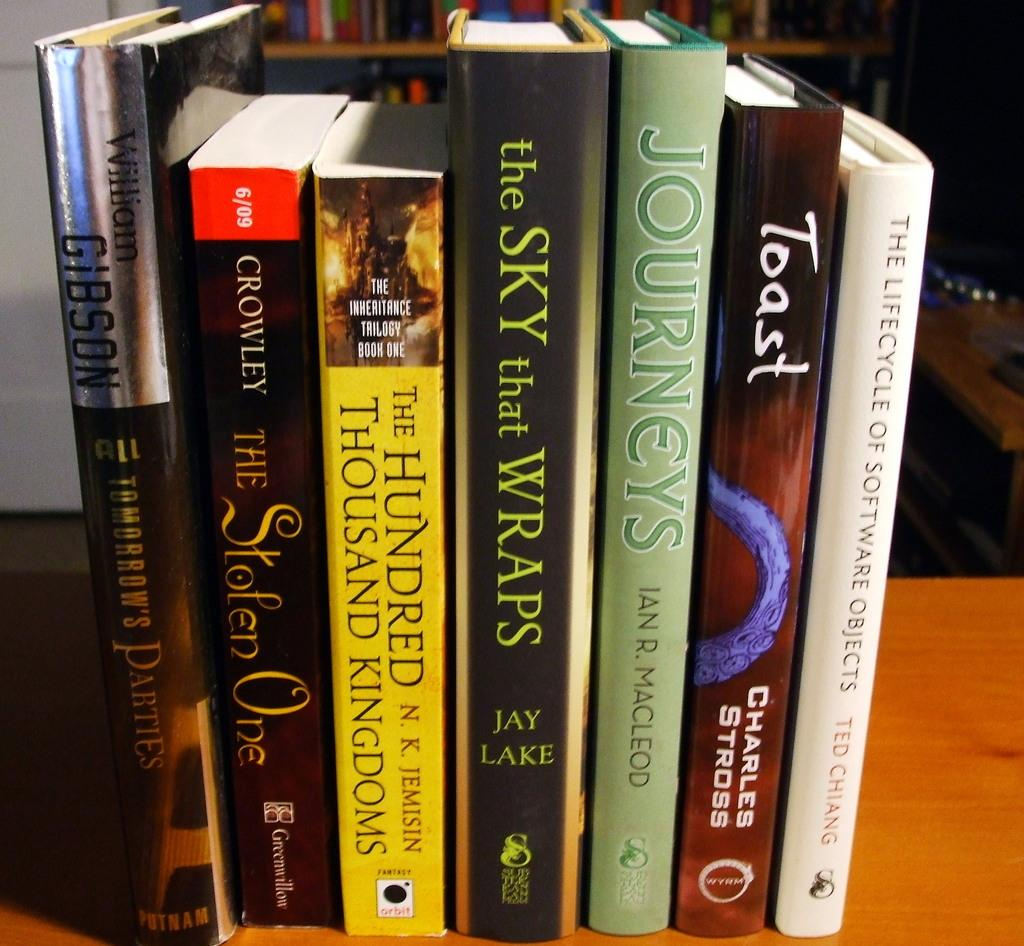<image>
Present a compact description of the photo's key features. A book by Jay Lake is surrounded by other books. 